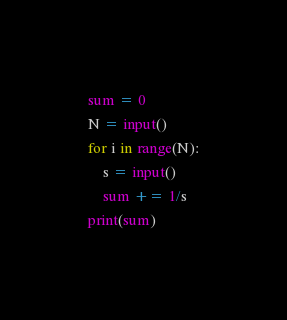<code> <loc_0><loc_0><loc_500><loc_500><_Python_>sum = 0
N = input() 
for i in range(N):
	s = input()
	sum += 1/s
print(sum)</code> 